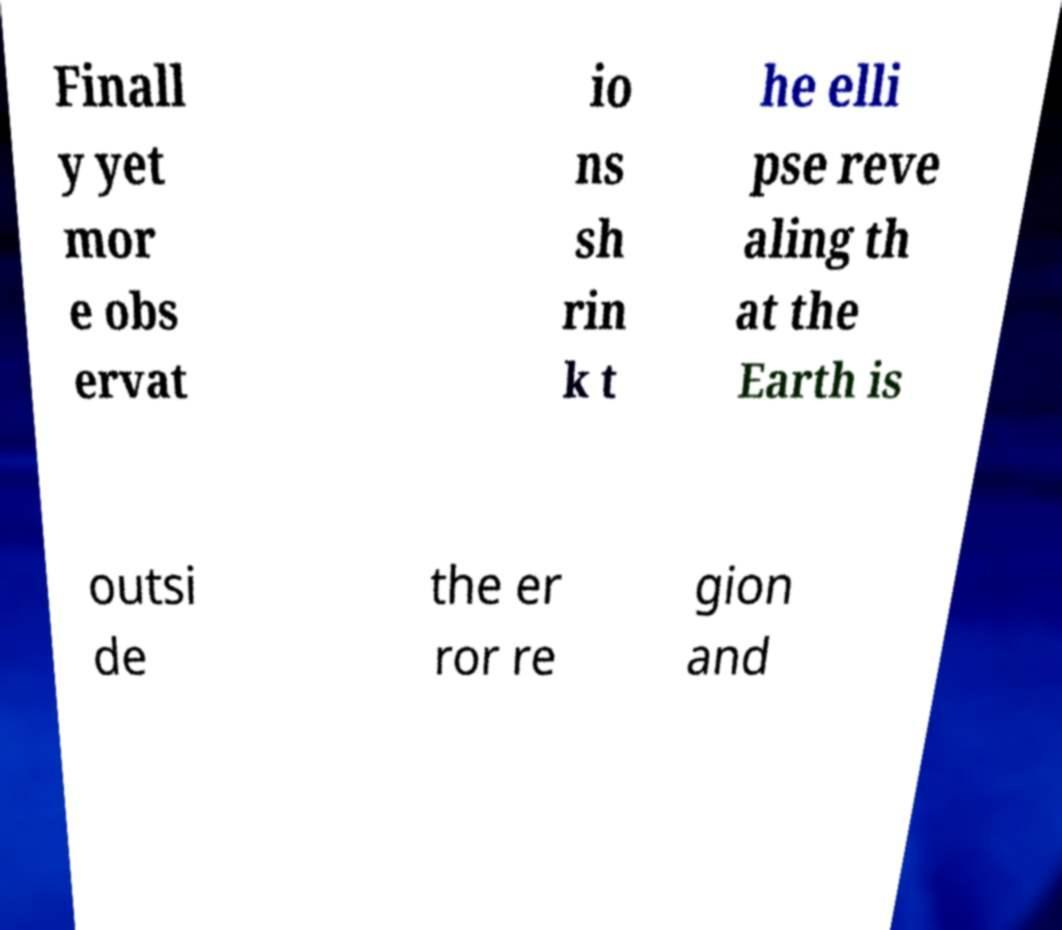Could you assist in decoding the text presented in this image and type it out clearly? Finall y yet mor e obs ervat io ns sh rin k t he elli pse reve aling th at the Earth is outsi de the er ror re gion and 